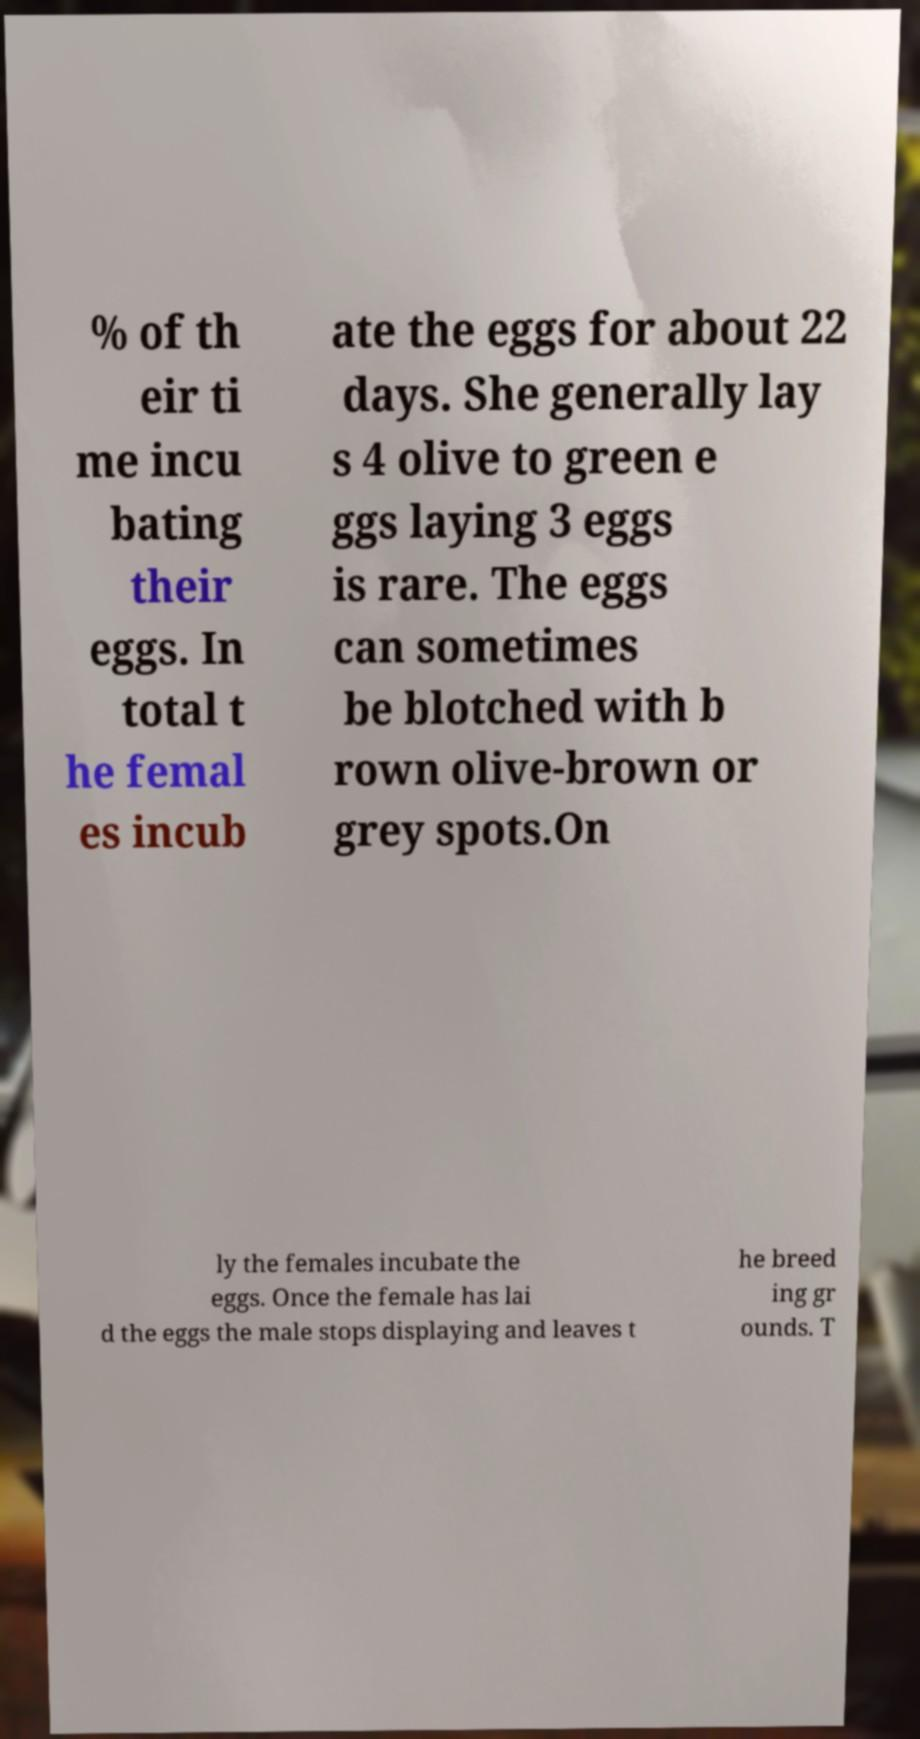Can you accurately transcribe the text from the provided image for me? % of th eir ti me incu bating their eggs. In total t he femal es incub ate the eggs for about 22 days. She generally lay s 4 olive to green e ggs laying 3 eggs is rare. The eggs can sometimes be blotched with b rown olive-brown or grey spots.On ly the females incubate the eggs. Once the female has lai d the eggs the male stops displaying and leaves t he breed ing gr ounds. T 